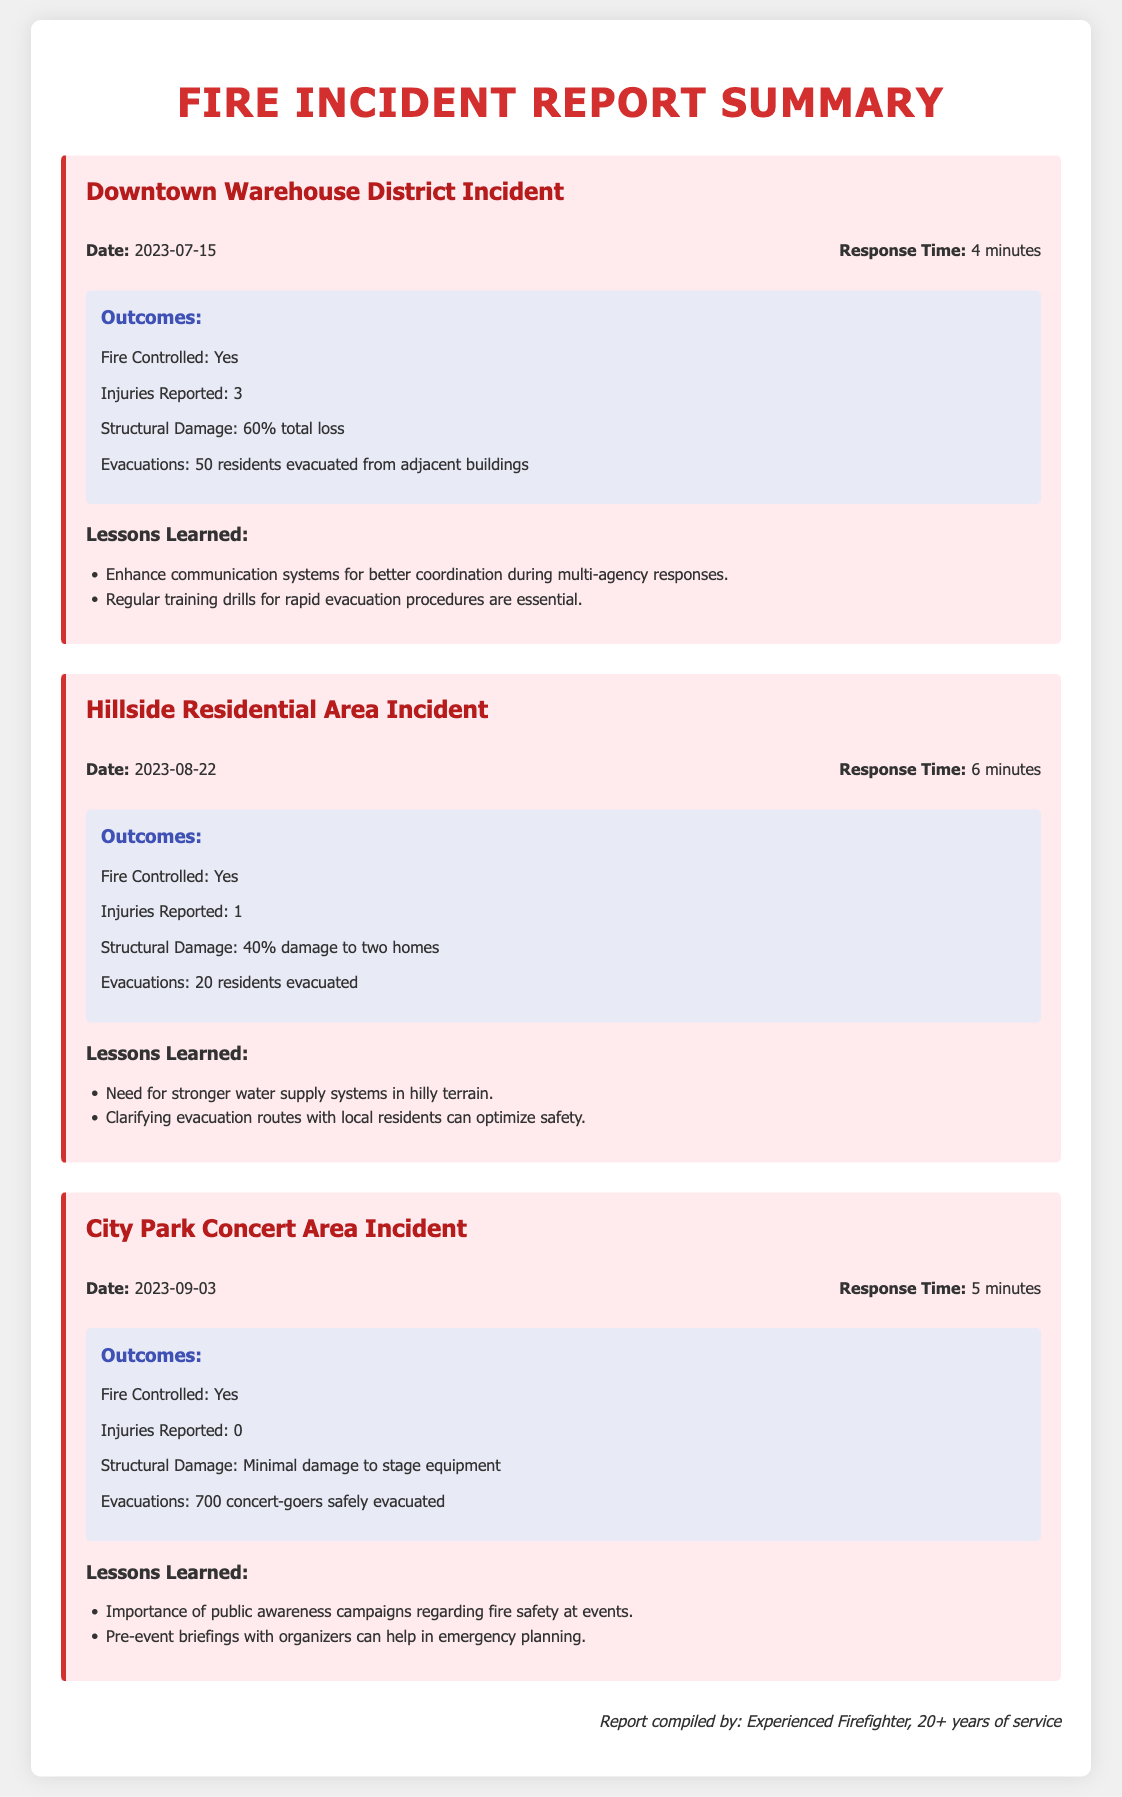What was the response time for the Downtown Warehouse District Incident? The response time for the Downtown Warehouse District Incident is directly stated in the document.
Answer: 4 minutes How many injuries were reported in the Hillside Residential Area Incident? The number of injuries reported is mentioned in the outcomes of the Hillside Residential Area Incident.
Answer: 1 What was the structural damage for the City Park Concert Area Incident? The structural damage is specified in the outcomes section for the City Park Concert Area Incident.
Answer: Minimal damage to stage equipment What lesson was learned regarding evacuation routes? One of the lessons learned about evacuation routes is articulated in the Hillside Residential Area incident section.
Answer: Clarifying evacuation routes with local residents can optimize safety Which incident had the most evacuations? By comparing the evacuations detail in each incident, we find which one had the highest number of evacuations.
Answer: City Park Concert Area Incident (700 concert-goers) 